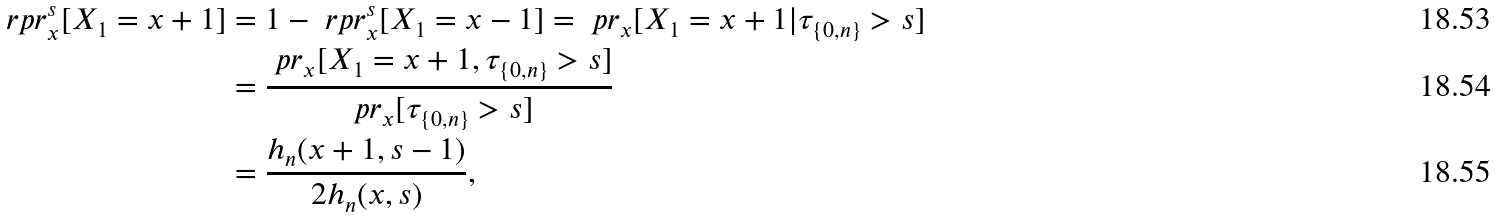<formula> <loc_0><loc_0><loc_500><loc_500>\ r p r ^ { s } _ { x } [ X _ { 1 } = x + 1 ] & = 1 - \ r p r ^ { s } _ { x } [ X _ { 1 } = x - 1 ] = \ p r _ { x } [ X _ { 1 } = x + 1 | \tau _ { \{ 0 , n \} } > s ] \\ & = \frac { \ p r _ { x } [ X _ { 1 } = x + 1 , \tau _ { \{ 0 , n \} } > s ] } { \ p r _ { x } [ \tau _ { \{ 0 , n \} } > s ] } \\ & = \frac { h _ { n } ( x + 1 , s - 1 ) } { 2 h _ { n } ( x , s ) } ,</formula> 